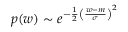Convert formula to latex. <formula><loc_0><loc_0><loc_500><loc_500>p ( w ) \sim e ^ { - \frac { 1 } { 2 } \left ( \frac { w - m } { \sigma } \right ) ^ { 2 } }</formula> 